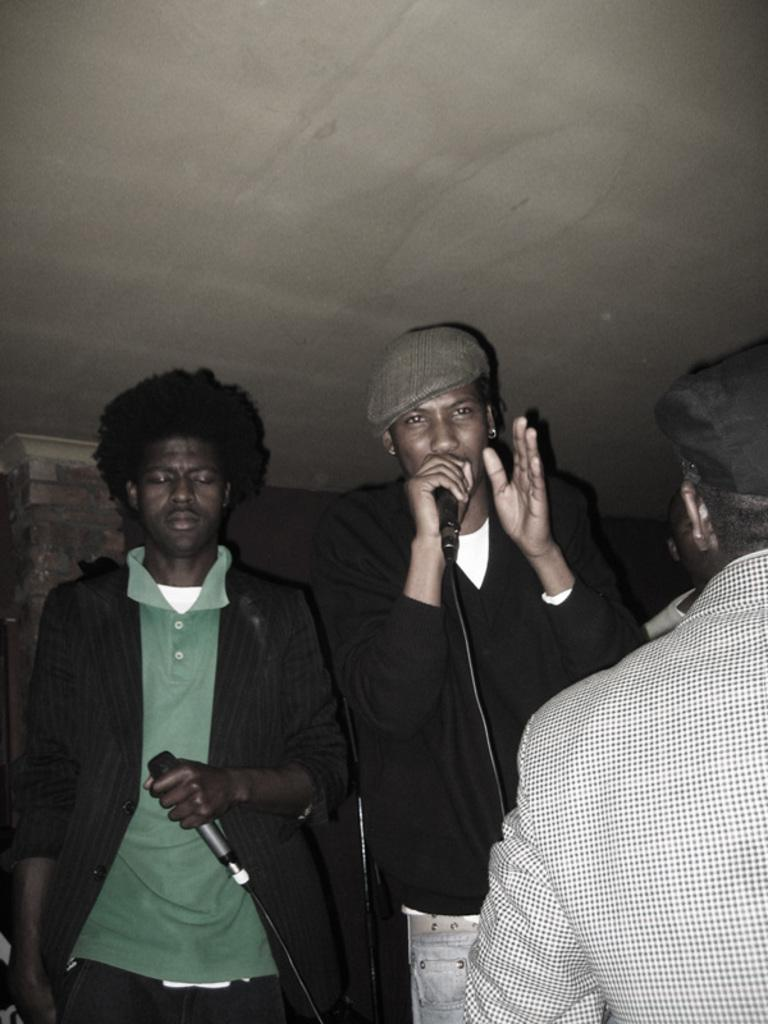How many people are present in the image? There are three people in the image. What is one person doing in the image? One person is singing. What object is being held by another person in the image? Another person is holding a microphone. What can be seen in the background of the image? There is a wall in the background of the image. What type of flag is being waved by the person in the image? There is no flag present in the image; only three people, one singing and another holding a microphone, are visible. 